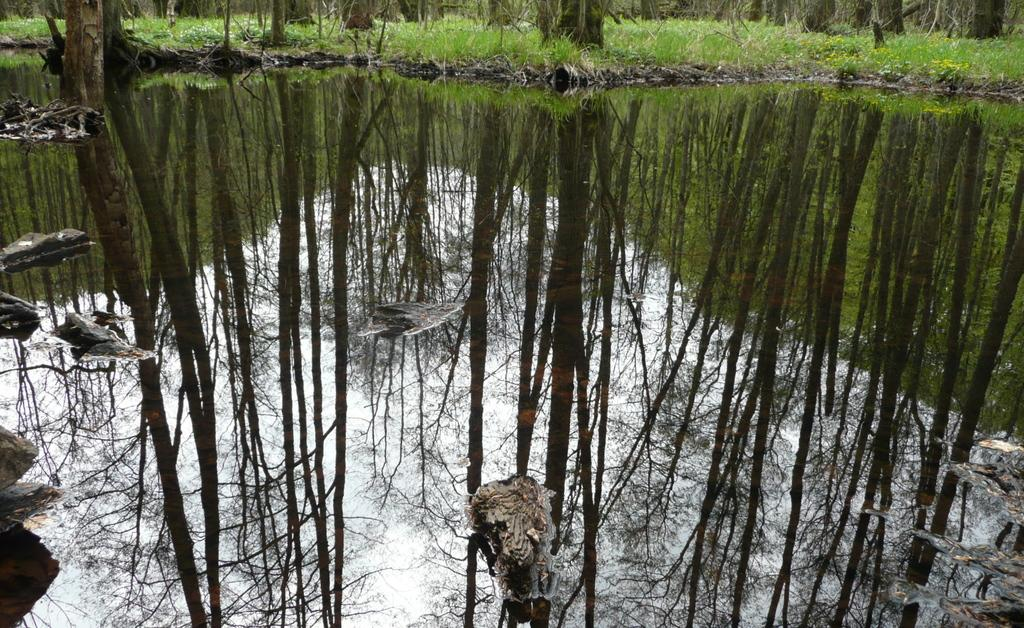What type of body of water is present in the image? There is a pond in the image. Where is the pond located in relation to the image? The pond is in the front of the image. What type of vegetation can be seen in the image? There are many trees in the image. What is the landscape surrounding the trees? The trees are on a grassland. Where is the grassland located in relation to the image? The grassland is in the back of the image. What type of thread can be seen hanging from the trees in the image? There is no thread visible in the image; it only features a pond, trees, and a grassland. 